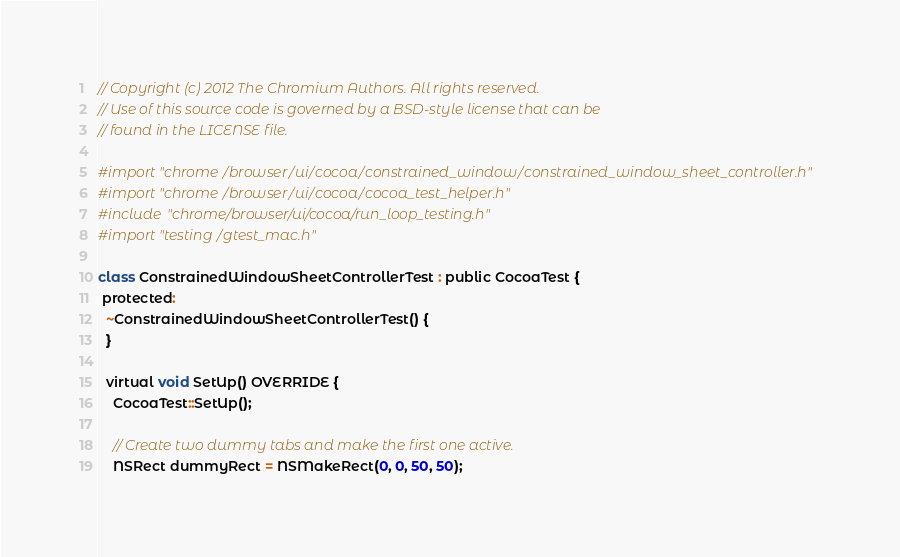<code> <loc_0><loc_0><loc_500><loc_500><_ObjectiveC_>// Copyright (c) 2012 The Chromium Authors. All rights reserved.
// Use of this source code is governed by a BSD-style license that can be
// found in the LICENSE file.

#import "chrome/browser/ui/cocoa/constrained_window/constrained_window_sheet_controller.h"
#import "chrome/browser/ui/cocoa/cocoa_test_helper.h"
#include "chrome/browser/ui/cocoa/run_loop_testing.h"
#import "testing/gtest_mac.h"

class ConstrainedWindowSheetControllerTest : public CocoaTest {
 protected:
  ~ConstrainedWindowSheetControllerTest() {
  }

  virtual void SetUp() OVERRIDE {
    CocoaTest::SetUp();

    // Create two dummy tabs and make the first one active.
    NSRect dummyRect = NSMakeRect(0, 0, 50, 50);</code> 